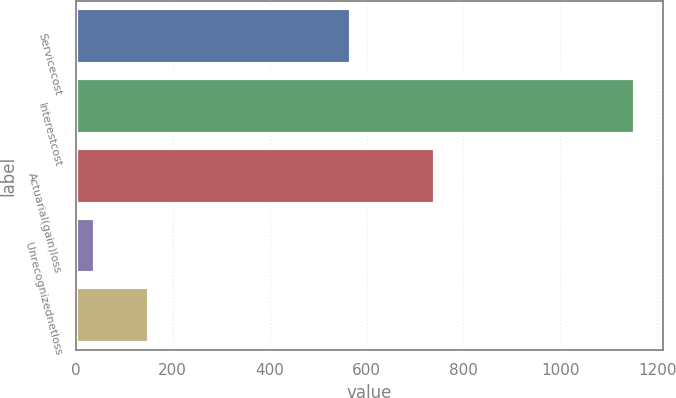<chart> <loc_0><loc_0><loc_500><loc_500><bar_chart><fcel>Servicecost<fcel>Interestcost<fcel>Actuarial(gain)loss<fcel>Unrecognizednetloss<fcel>Unnamed: 4<nl><fcel>567<fcel>1154<fcel>741<fcel>41<fcel>152.3<nl></chart> 